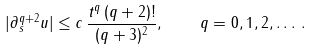<formula> <loc_0><loc_0><loc_500><loc_500>| \partial ^ { q + 2 } _ { s } u | \leq c \, \frac { t ^ { q } \, ( q + 2 ) ! } { ( q + 3 ) ^ { 2 } } , \quad q = 0 , 1 , 2 , \dots \, .</formula> 